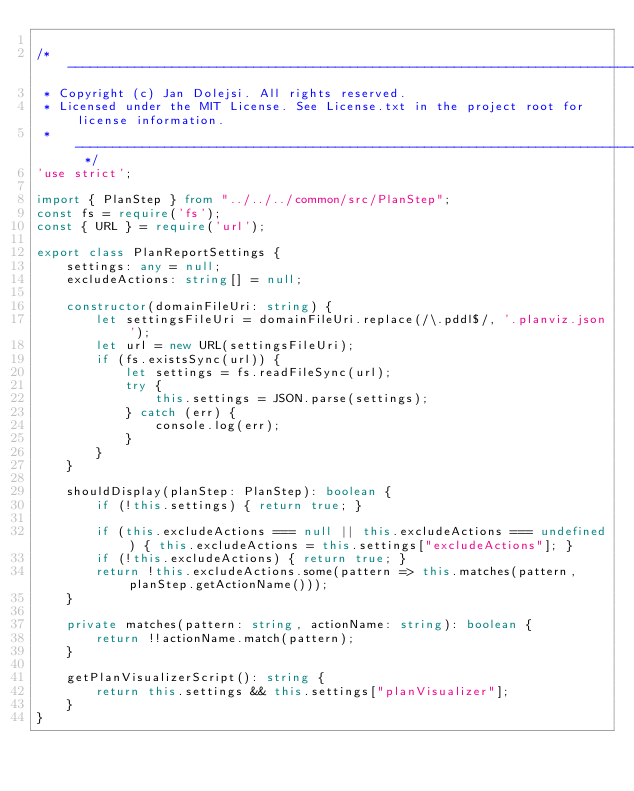Convert code to text. <code><loc_0><loc_0><loc_500><loc_500><_TypeScript_>
/* --------------------------------------------------------------------------------------------
 * Copyright (c) Jan Dolejsi. All rights reserved.
 * Licensed under the MIT License. See License.txt in the project root for license information.
 * ------------------------------------------------------------------------------------------ */
'use strict';

import { PlanStep } from "../../../common/src/PlanStep";
const fs = require('fs');
const { URL } = require('url');

export class PlanReportSettings {
    settings: any = null;
    excludeActions: string[] = null;

    constructor(domainFileUri: string) {
        let settingsFileUri = domainFileUri.replace(/\.pddl$/, '.planviz.json');
        let url = new URL(settingsFileUri);
        if (fs.existsSync(url)) {
            let settings = fs.readFileSync(url);
            try {
                this.settings = JSON.parse(settings);
            } catch (err) {
                console.log(err);
            }
        }
    }

    shouldDisplay(planStep: PlanStep): boolean {
        if (!this.settings) { return true; }

        if (this.excludeActions === null || this.excludeActions === undefined) { this.excludeActions = this.settings["excludeActions"]; }
        if (!this.excludeActions) { return true; }
        return !this.excludeActions.some(pattern => this.matches(pattern, planStep.getActionName()));
    }

    private matches(pattern: string, actionName: string): boolean {
        return !!actionName.match(pattern);
    }

    getPlanVisualizerScript(): string {
        return this.settings && this.settings["planVisualizer"];
    }
}</code> 